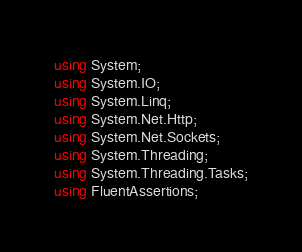<code> <loc_0><loc_0><loc_500><loc_500><_C#_>using System;
using System.IO;
using System.Linq;
using System.Net.Http;
using System.Net.Sockets;
using System.Threading;
using System.Threading.Tasks;
using FluentAssertions;</code> 